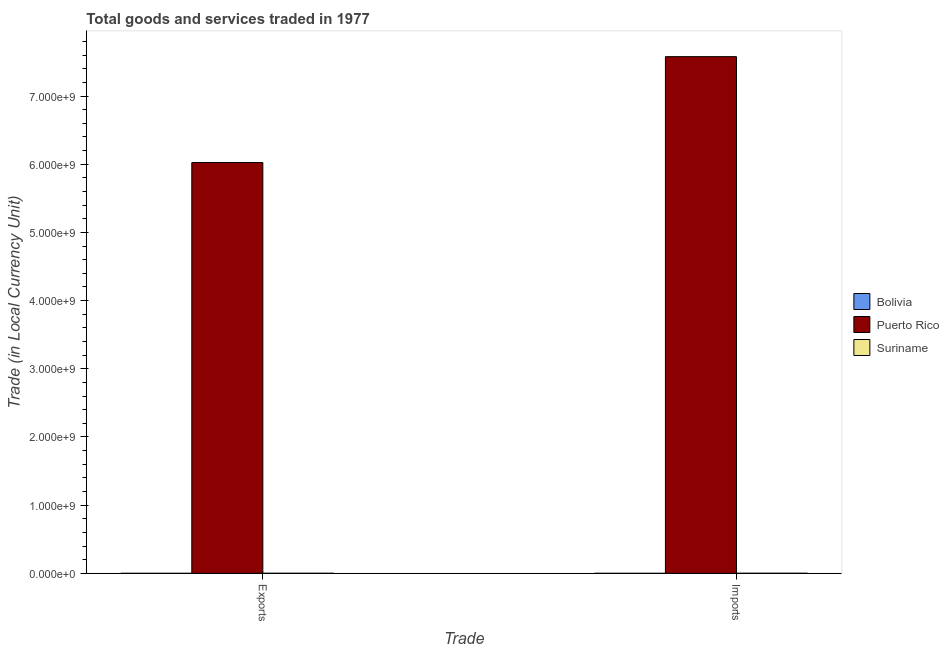How many groups of bars are there?
Keep it short and to the point. 2. How many bars are there on the 2nd tick from the left?
Ensure brevity in your answer.  3. What is the label of the 1st group of bars from the left?
Make the answer very short. Exports. What is the imports of goods and services in Bolivia?
Your response must be concise. 1.91e+04. Across all countries, what is the maximum export of goods and services?
Provide a short and direct response. 6.02e+09. Across all countries, what is the minimum imports of goods and services?
Your answer should be very brief. 1.91e+04. In which country was the export of goods and services maximum?
Offer a terse response. Puerto Rico. In which country was the imports of goods and services minimum?
Offer a terse response. Bolivia. What is the total imports of goods and services in the graph?
Offer a terse response. 7.58e+09. What is the difference between the export of goods and services in Suriname and that in Bolivia?
Keep it short and to the point. 6.90e+05. What is the difference between the export of goods and services in Suriname and the imports of goods and services in Bolivia?
Keep it short and to the point. 6.88e+05. What is the average imports of goods and services per country?
Provide a short and direct response. 2.53e+09. What is the difference between the export of goods and services and imports of goods and services in Bolivia?
Keep it short and to the point. -1855. In how many countries, is the imports of goods and services greater than 6000000000 LCU?
Give a very brief answer. 1. What is the ratio of the export of goods and services in Puerto Rico to that in Suriname?
Give a very brief answer. 8521.92. In how many countries, is the export of goods and services greater than the average export of goods and services taken over all countries?
Your response must be concise. 1. What does the 2nd bar from the left in Imports represents?
Offer a terse response. Puerto Rico. What does the 2nd bar from the right in Exports represents?
Offer a very short reply. Puerto Rico. How many countries are there in the graph?
Make the answer very short. 3. What is the difference between two consecutive major ticks on the Y-axis?
Offer a terse response. 1.00e+09. Are the values on the major ticks of Y-axis written in scientific E-notation?
Your response must be concise. Yes. Does the graph contain any zero values?
Keep it short and to the point. No. How many legend labels are there?
Ensure brevity in your answer.  3. How are the legend labels stacked?
Make the answer very short. Vertical. What is the title of the graph?
Make the answer very short. Total goods and services traded in 1977. Does "Malaysia" appear as one of the legend labels in the graph?
Provide a short and direct response. No. What is the label or title of the X-axis?
Offer a very short reply. Trade. What is the label or title of the Y-axis?
Give a very brief answer. Trade (in Local Currency Unit). What is the Trade (in Local Currency Unit) of Bolivia in Exports?
Your response must be concise. 1.73e+04. What is the Trade (in Local Currency Unit) in Puerto Rico in Exports?
Offer a very short reply. 6.02e+09. What is the Trade (in Local Currency Unit) of Suriname in Exports?
Your answer should be compact. 7.07e+05. What is the Trade (in Local Currency Unit) in Bolivia in Imports?
Offer a very short reply. 1.91e+04. What is the Trade (in Local Currency Unit) in Puerto Rico in Imports?
Your response must be concise. 7.58e+09. What is the Trade (in Local Currency Unit) in Suriname in Imports?
Your response must be concise. 7.95e+05. Across all Trade, what is the maximum Trade (in Local Currency Unit) in Bolivia?
Provide a succinct answer. 1.91e+04. Across all Trade, what is the maximum Trade (in Local Currency Unit) of Puerto Rico?
Provide a short and direct response. 7.58e+09. Across all Trade, what is the maximum Trade (in Local Currency Unit) of Suriname?
Give a very brief answer. 7.95e+05. Across all Trade, what is the minimum Trade (in Local Currency Unit) in Bolivia?
Ensure brevity in your answer.  1.73e+04. Across all Trade, what is the minimum Trade (in Local Currency Unit) of Puerto Rico?
Your answer should be very brief. 6.02e+09. Across all Trade, what is the minimum Trade (in Local Currency Unit) in Suriname?
Your response must be concise. 7.07e+05. What is the total Trade (in Local Currency Unit) of Bolivia in the graph?
Your response must be concise. 3.64e+04. What is the total Trade (in Local Currency Unit) in Puerto Rico in the graph?
Ensure brevity in your answer.  1.36e+1. What is the total Trade (in Local Currency Unit) of Suriname in the graph?
Offer a very short reply. 1.50e+06. What is the difference between the Trade (in Local Currency Unit) of Bolivia in Exports and that in Imports?
Offer a terse response. -1855. What is the difference between the Trade (in Local Currency Unit) of Puerto Rico in Exports and that in Imports?
Keep it short and to the point. -1.55e+09. What is the difference between the Trade (in Local Currency Unit) in Suriname in Exports and that in Imports?
Provide a short and direct response. -8.80e+04. What is the difference between the Trade (in Local Currency Unit) in Bolivia in Exports and the Trade (in Local Currency Unit) in Puerto Rico in Imports?
Your answer should be compact. -7.58e+09. What is the difference between the Trade (in Local Currency Unit) in Bolivia in Exports and the Trade (in Local Currency Unit) in Suriname in Imports?
Offer a very short reply. -7.78e+05. What is the difference between the Trade (in Local Currency Unit) in Puerto Rico in Exports and the Trade (in Local Currency Unit) in Suriname in Imports?
Make the answer very short. 6.02e+09. What is the average Trade (in Local Currency Unit) of Bolivia per Trade?
Offer a very short reply. 1.82e+04. What is the average Trade (in Local Currency Unit) of Puerto Rico per Trade?
Offer a very short reply. 6.80e+09. What is the average Trade (in Local Currency Unit) of Suriname per Trade?
Your response must be concise. 7.51e+05. What is the difference between the Trade (in Local Currency Unit) of Bolivia and Trade (in Local Currency Unit) of Puerto Rico in Exports?
Your answer should be compact. -6.02e+09. What is the difference between the Trade (in Local Currency Unit) of Bolivia and Trade (in Local Currency Unit) of Suriname in Exports?
Offer a terse response. -6.90e+05. What is the difference between the Trade (in Local Currency Unit) in Puerto Rico and Trade (in Local Currency Unit) in Suriname in Exports?
Offer a very short reply. 6.02e+09. What is the difference between the Trade (in Local Currency Unit) of Bolivia and Trade (in Local Currency Unit) of Puerto Rico in Imports?
Keep it short and to the point. -7.58e+09. What is the difference between the Trade (in Local Currency Unit) of Bolivia and Trade (in Local Currency Unit) of Suriname in Imports?
Keep it short and to the point. -7.76e+05. What is the difference between the Trade (in Local Currency Unit) in Puerto Rico and Trade (in Local Currency Unit) in Suriname in Imports?
Give a very brief answer. 7.58e+09. What is the ratio of the Trade (in Local Currency Unit) in Bolivia in Exports to that in Imports?
Offer a terse response. 0.9. What is the ratio of the Trade (in Local Currency Unit) in Puerto Rico in Exports to that in Imports?
Your answer should be very brief. 0.8. What is the ratio of the Trade (in Local Currency Unit) in Suriname in Exports to that in Imports?
Offer a very short reply. 0.89. What is the difference between the highest and the second highest Trade (in Local Currency Unit) in Bolivia?
Keep it short and to the point. 1855. What is the difference between the highest and the second highest Trade (in Local Currency Unit) of Puerto Rico?
Provide a succinct answer. 1.55e+09. What is the difference between the highest and the second highest Trade (in Local Currency Unit) in Suriname?
Provide a succinct answer. 8.80e+04. What is the difference between the highest and the lowest Trade (in Local Currency Unit) in Bolivia?
Your answer should be very brief. 1855. What is the difference between the highest and the lowest Trade (in Local Currency Unit) in Puerto Rico?
Give a very brief answer. 1.55e+09. What is the difference between the highest and the lowest Trade (in Local Currency Unit) of Suriname?
Keep it short and to the point. 8.80e+04. 